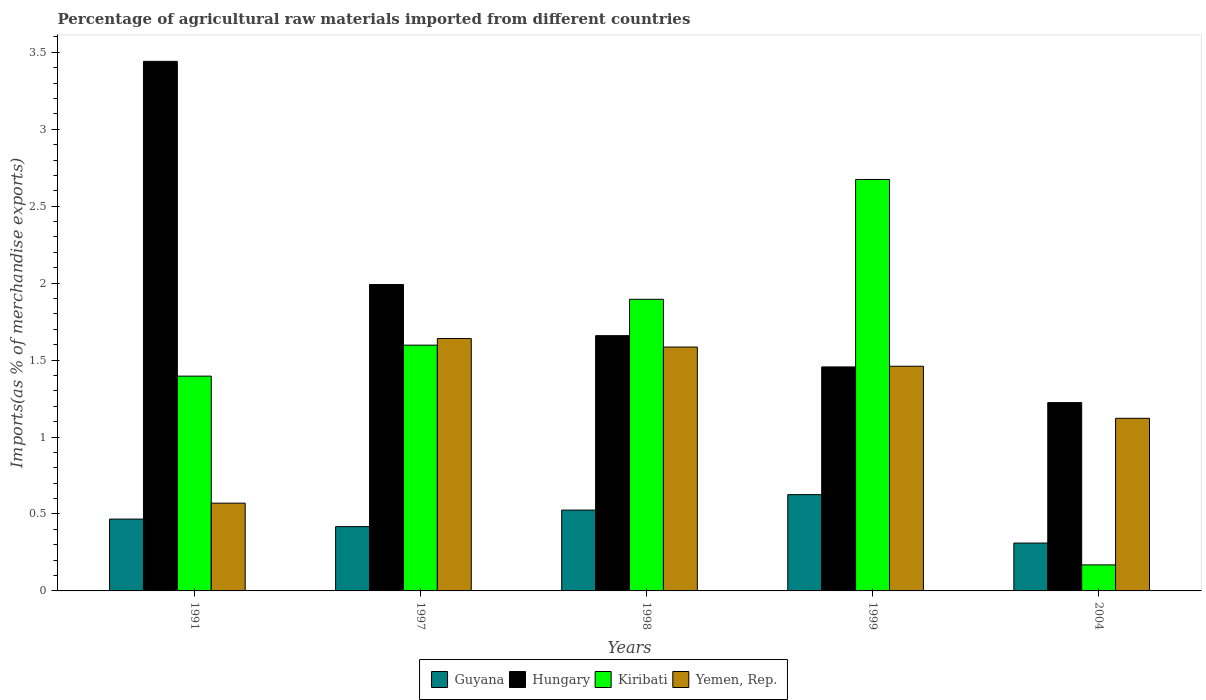Are the number of bars per tick equal to the number of legend labels?
Ensure brevity in your answer.  Yes. What is the label of the 3rd group of bars from the left?
Your answer should be very brief. 1998. What is the percentage of imports to different countries in Hungary in 1999?
Give a very brief answer. 1.46. Across all years, what is the maximum percentage of imports to different countries in Hungary?
Give a very brief answer. 3.44. Across all years, what is the minimum percentage of imports to different countries in Guyana?
Make the answer very short. 0.31. In which year was the percentage of imports to different countries in Guyana minimum?
Provide a short and direct response. 2004. What is the total percentage of imports to different countries in Yemen, Rep. in the graph?
Keep it short and to the point. 6.38. What is the difference between the percentage of imports to different countries in Hungary in 1991 and that in 1997?
Your answer should be compact. 1.45. What is the difference between the percentage of imports to different countries in Hungary in 1997 and the percentage of imports to different countries in Kiribati in 1991?
Offer a very short reply. 0.6. What is the average percentage of imports to different countries in Hungary per year?
Your response must be concise. 1.95. In the year 2004, what is the difference between the percentage of imports to different countries in Guyana and percentage of imports to different countries in Kiribati?
Offer a very short reply. 0.14. What is the ratio of the percentage of imports to different countries in Guyana in 1991 to that in 2004?
Provide a short and direct response. 1.5. Is the difference between the percentage of imports to different countries in Guyana in 1991 and 1997 greater than the difference between the percentage of imports to different countries in Kiribati in 1991 and 1997?
Ensure brevity in your answer.  Yes. What is the difference between the highest and the second highest percentage of imports to different countries in Hungary?
Your answer should be compact. 1.45. What is the difference between the highest and the lowest percentage of imports to different countries in Guyana?
Provide a succinct answer. 0.31. In how many years, is the percentage of imports to different countries in Guyana greater than the average percentage of imports to different countries in Guyana taken over all years?
Offer a terse response. 2. Is it the case that in every year, the sum of the percentage of imports to different countries in Guyana and percentage of imports to different countries in Yemen, Rep. is greater than the sum of percentage of imports to different countries in Hungary and percentage of imports to different countries in Kiribati?
Provide a succinct answer. No. What does the 3rd bar from the left in 1998 represents?
Your answer should be very brief. Kiribati. What does the 4th bar from the right in 1997 represents?
Ensure brevity in your answer.  Guyana. Is it the case that in every year, the sum of the percentage of imports to different countries in Yemen, Rep. and percentage of imports to different countries in Hungary is greater than the percentage of imports to different countries in Guyana?
Give a very brief answer. Yes. How many bars are there?
Make the answer very short. 20. Does the graph contain any zero values?
Keep it short and to the point. No. How many legend labels are there?
Give a very brief answer. 4. How are the legend labels stacked?
Your answer should be very brief. Horizontal. What is the title of the graph?
Your response must be concise. Percentage of agricultural raw materials imported from different countries. Does "Israel" appear as one of the legend labels in the graph?
Ensure brevity in your answer.  No. What is the label or title of the X-axis?
Your answer should be compact. Years. What is the label or title of the Y-axis?
Give a very brief answer. Imports(as % of merchandise exports). What is the Imports(as % of merchandise exports) of Guyana in 1991?
Offer a very short reply. 0.47. What is the Imports(as % of merchandise exports) of Hungary in 1991?
Ensure brevity in your answer.  3.44. What is the Imports(as % of merchandise exports) of Kiribati in 1991?
Provide a succinct answer. 1.4. What is the Imports(as % of merchandise exports) in Yemen, Rep. in 1991?
Give a very brief answer. 0.57. What is the Imports(as % of merchandise exports) of Guyana in 1997?
Make the answer very short. 0.42. What is the Imports(as % of merchandise exports) in Hungary in 1997?
Offer a very short reply. 1.99. What is the Imports(as % of merchandise exports) in Kiribati in 1997?
Offer a terse response. 1.6. What is the Imports(as % of merchandise exports) of Yemen, Rep. in 1997?
Keep it short and to the point. 1.64. What is the Imports(as % of merchandise exports) of Guyana in 1998?
Provide a short and direct response. 0.53. What is the Imports(as % of merchandise exports) of Hungary in 1998?
Your answer should be compact. 1.66. What is the Imports(as % of merchandise exports) in Kiribati in 1998?
Keep it short and to the point. 1.89. What is the Imports(as % of merchandise exports) in Yemen, Rep. in 1998?
Your answer should be compact. 1.58. What is the Imports(as % of merchandise exports) of Guyana in 1999?
Offer a very short reply. 0.63. What is the Imports(as % of merchandise exports) of Hungary in 1999?
Keep it short and to the point. 1.46. What is the Imports(as % of merchandise exports) in Kiribati in 1999?
Your answer should be very brief. 2.67. What is the Imports(as % of merchandise exports) in Yemen, Rep. in 1999?
Your response must be concise. 1.46. What is the Imports(as % of merchandise exports) of Guyana in 2004?
Make the answer very short. 0.31. What is the Imports(as % of merchandise exports) in Hungary in 2004?
Ensure brevity in your answer.  1.22. What is the Imports(as % of merchandise exports) of Kiribati in 2004?
Provide a short and direct response. 0.17. What is the Imports(as % of merchandise exports) of Yemen, Rep. in 2004?
Your answer should be compact. 1.12. Across all years, what is the maximum Imports(as % of merchandise exports) of Guyana?
Your response must be concise. 0.63. Across all years, what is the maximum Imports(as % of merchandise exports) in Hungary?
Provide a succinct answer. 3.44. Across all years, what is the maximum Imports(as % of merchandise exports) of Kiribati?
Your response must be concise. 2.67. Across all years, what is the maximum Imports(as % of merchandise exports) in Yemen, Rep.?
Make the answer very short. 1.64. Across all years, what is the minimum Imports(as % of merchandise exports) of Guyana?
Offer a terse response. 0.31. Across all years, what is the minimum Imports(as % of merchandise exports) in Hungary?
Offer a very short reply. 1.22. Across all years, what is the minimum Imports(as % of merchandise exports) of Kiribati?
Make the answer very short. 0.17. Across all years, what is the minimum Imports(as % of merchandise exports) of Yemen, Rep.?
Keep it short and to the point. 0.57. What is the total Imports(as % of merchandise exports) in Guyana in the graph?
Keep it short and to the point. 2.35. What is the total Imports(as % of merchandise exports) in Hungary in the graph?
Keep it short and to the point. 9.77. What is the total Imports(as % of merchandise exports) in Kiribati in the graph?
Provide a succinct answer. 7.73. What is the total Imports(as % of merchandise exports) in Yemen, Rep. in the graph?
Provide a succinct answer. 6.38. What is the difference between the Imports(as % of merchandise exports) of Guyana in 1991 and that in 1997?
Your answer should be very brief. 0.05. What is the difference between the Imports(as % of merchandise exports) in Hungary in 1991 and that in 1997?
Give a very brief answer. 1.45. What is the difference between the Imports(as % of merchandise exports) in Kiribati in 1991 and that in 1997?
Your answer should be very brief. -0.2. What is the difference between the Imports(as % of merchandise exports) in Yemen, Rep. in 1991 and that in 1997?
Make the answer very short. -1.07. What is the difference between the Imports(as % of merchandise exports) in Guyana in 1991 and that in 1998?
Your answer should be compact. -0.06. What is the difference between the Imports(as % of merchandise exports) of Hungary in 1991 and that in 1998?
Offer a very short reply. 1.78. What is the difference between the Imports(as % of merchandise exports) of Kiribati in 1991 and that in 1998?
Give a very brief answer. -0.5. What is the difference between the Imports(as % of merchandise exports) in Yemen, Rep. in 1991 and that in 1998?
Offer a terse response. -1.01. What is the difference between the Imports(as % of merchandise exports) in Guyana in 1991 and that in 1999?
Provide a short and direct response. -0.16. What is the difference between the Imports(as % of merchandise exports) in Hungary in 1991 and that in 1999?
Your answer should be compact. 1.99. What is the difference between the Imports(as % of merchandise exports) in Kiribati in 1991 and that in 1999?
Your answer should be very brief. -1.28. What is the difference between the Imports(as % of merchandise exports) of Yemen, Rep. in 1991 and that in 1999?
Provide a short and direct response. -0.89. What is the difference between the Imports(as % of merchandise exports) of Guyana in 1991 and that in 2004?
Ensure brevity in your answer.  0.16. What is the difference between the Imports(as % of merchandise exports) of Hungary in 1991 and that in 2004?
Provide a succinct answer. 2.22. What is the difference between the Imports(as % of merchandise exports) in Kiribati in 1991 and that in 2004?
Give a very brief answer. 1.23. What is the difference between the Imports(as % of merchandise exports) of Yemen, Rep. in 1991 and that in 2004?
Keep it short and to the point. -0.55. What is the difference between the Imports(as % of merchandise exports) in Guyana in 1997 and that in 1998?
Offer a very short reply. -0.11. What is the difference between the Imports(as % of merchandise exports) of Hungary in 1997 and that in 1998?
Your response must be concise. 0.33. What is the difference between the Imports(as % of merchandise exports) of Kiribati in 1997 and that in 1998?
Provide a succinct answer. -0.3. What is the difference between the Imports(as % of merchandise exports) of Yemen, Rep. in 1997 and that in 1998?
Your answer should be compact. 0.06. What is the difference between the Imports(as % of merchandise exports) in Guyana in 1997 and that in 1999?
Your response must be concise. -0.21. What is the difference between the Imports(as % of merchandise exports) in Hungary in 1997 and that in 1999?
Your response must be concise. 0.54. What is the difference between the Imports(as % of merchandise exports) of Kiribati in 1997 and that in 1999?
Your answer should be compact. -1.08. What is the difference between the Imports(as % of merchandise exports) in Yemen, Rep. in 1997 and that in 1999?
Your response must be concise. 0.18. What is the difference between the Imports(as % of merchandise exports) of Guyana in 1997 and that in 2004?
Your response must be concise. 0.11. What is the difference between the Imports(as % of merchandise exports) in Hungary in 1997 and that in 2004?
Provide a short and direct response. 0.77. What is the difference between the Imports(as % of merchandise exports) of Kiribati in 1997 and that in 2004?
Your answer should be very brief. 1.43. What is the difference between the Imports(as % of merchandise exports) in Yemen, Rep. in 1997 and that in 2004?
Keep it short and to the point. 0.52. What is the difference between the Imports(as % of merchandise exports) in Guyana in 1998 and that in 1999?
Give a very brief answer. -0.1. What is the difference between the Imports(as % of merchandise exports) in Hungary in 1998 and that in 1999?
Provide a succinct answer. 0.2. What is the difference between the Imports(as % of merchandise exports) of Kiribati in 1998 and that in 1999?
Provide a succinct answer. -0.78. What is the difference between the Imports(as % of merchandise exports) in Yemen, Rep. in 1998 and that in 1999?
Ensure brevity in your answer.  0.12. What is the difference between the Imports(as % of merchandise exports) in Guyana in 1998 and that in 2004?
Your answer should be very brief. 0.21. What is the difference between the Imports(as % of merchandise exports) in Hungary in 1998 and that in 2004?
Your answer should be very brief. 0.43. What is the difference between the Imports(as % of merchandise exports) in Kiribati in 1998 and that in 2004?
Your response must be concise. 1.73. What is the difference between the Imports(as % of merchandise exports) of Yemen, Rep. in 1998 and that in 2004?
Offer a terse response. 0.46. What is the difference between the Imports(as % of merchandise exports) of Guyana in 1999 and that in 2004?
Keep it short and to the point. 0.31. What is the difference between the Imports(as % of merchandise exports) in Hungary in 1999 and that in 2004?
Your answer should be compact. 0.23. What is the difference between the Imports(as % of merchandise exports) of Kiribati in 1999 and that in 2004?
Provide a succinct answer. 2.5. What is the difference between the Imports(as % of merchandise exports) in Yemen, Rep. in 1999 and that in 2004?
Provide a succinct answer. 0.34. What is the difference between the Imports(as % of merchandise exports) of Guyana in 1991 and the Imports(as % of merchandise exports) of Hungary in 1997?
Your response must be concise. -1.52. What is the difference between the Imports(as % of merchandise exports) of Guyana in 1991 and the Imports(as % of merchandise exports) of Kiribati in 1997?
Provide a succinct answer. -1.13. What is the difference between the Imports(as % of merchandise exports) in Guyana in 1991 and the Imports(as % of merchandise exports) in Yemen, Rep. in 1997?
Provide a succinct answer. -1.17. What is the difference between the Imports(as % of merchandise exports) of Hungary in 1991 and the Imports(as % of merchandise exports) of Kiribati in 1997?
Give a very brief answer. 1.84. What is the difference between the Imports(as % of merchandise exports) of Hungary in 1991 and the Imports(as % of merchandise exports) of Yemen, Rep. in 1997?
Provide a short and direct response. 1.8. What is the difference between the Imports(as % of merchandise exports) of Kiribati in 1991 and the Imports(as % of merchandise exports) of Yemen, Rep. in 1997?
Make the answer very short. -0.24. What is the difference between the Imports(as % of merchandise exports) of Guyana in 1991 and the Imports(as % of merchandise exports) of Hungary in 1998?
Offer a terse response. -1.19. What is the difference between the Imports(as % of merchandise exports) of Guyana in 1991 and the Imports(as % of merchandise exports) of Kiribati in 1998?
Offer a terse response. -1.43. What is the difference between the Imports(as % of merchandise exports) in Guyana in 1991 and the Imports(as % of merchandise exports) in Yemen, Rep. in 1998?
Your response must be concise. -1.12. What is the difference between the Imports(as % of merchandise exports) of Hungary in 1991 and the Imports(as % of merchandise exports) of Kiribati in 1998?
Your answer should be very brief. 1.55. What is the difference between the Imports(as % of merchandise exports) in Hungary in 1991 and the Imports(as % of merchandise exports) in Yemen, Rep. in 1998?
Make the answer very short. 1.86. What is the difference between the Imports(as % of merchandise exports) of Kiribati in 1991 and the Imports(as % of merchandise exports) of Yemen, Rep. in 1998?
Make the answer very short. -0.19. What is the difference between the Imports(as % of merchandise exports) in Guyana in 1991 and the Imports(as % of merchandise exports) in Hungary in 1999?
Offer a terse response. -0.99. What is the difference between the Imports(as % of merchandise exports) in Guyana in 1991 and the Imports(as % of merchandise exports) in Kiribati in 1999?
Your response must be concise. -2.21. What is the difference between the Imports(as % of merchandise exports) of Guyana in 1991 and the Imports(as % of merchandise exports) of Yemen, Rep. in 1999?
Offer a very short reply. -0.99. What is the difference between the Imports(as % of merchandise exports) of Hungary in 1991 and the Imports(as % of merchandise exports) of Kiribati in 1999?
Offer a terse response. 0.77. What is the difference between the Imports(as % of merchandise exports) in Hungary in 1991 and the Imports(as % of merchandise exports) in Yemen, Rep. in 1999?
Your response must be concise. 1.98. What is the difference between the Imports(as % of merchandise exports) in Kiribati in 1991 and the Imports(as % of merchandise exports) in Yemen, Rep. in 1999?
Give a very brief answer. -0.06. What is the difference between the Imports(as % of merchandise exports) in Guyana in 1991 and the Imports(as % of merchandise exports) in Hungary in 2004?
Offer a terse response. -0.76. What is the difference between the Imports(as % of merchandise exports) of Guyana in 1991 and the Imports(as % of merchandise exports) of Kiribati in 2004?
Your answer should be compact. 0.3. What is the difference between the Imports(as % of merchandise exports) in Guyana in 1991 and the Imports(as % of merchandise exports) in Yemen, Rep. in 2004?
Offer a terse response. -0.65. What is the difference between the Imports(as % of merchandise exports) in Hungary in 1991 and the Imports(as % of merchandise exports) in Kiribati in 2004?
Your answer should be very brief. 3.27. What is the difference between the Imports(as % of merchandise exports) in Hungary in 1991 and the Imports(as % of merchandise exports) in Yemen, Rep. in 2004?
Offer a terse response. 2.32. What is the difference between the Imports(as % of merchandise exports) in Kiribati in 1991 and the Imports(as % of merchandise exports) in Yemen, Rep. in 2004?
Make the answer very short. 0.27. What is the difference between the Imports(as % of merchandise exports) of Guyana in 1997 and the Imports(as % of merchandise exports) of Hungary in 1998?
Offer a terse response. -1.24. What is the difference between the Imports(as % of merchandise exports) of Guyana in 1997 and the Imports(as % of merchandise exports) of Kiribati in 1998?
Your answer should be very brief. -1.48. What is the difference between the Imports(as % of merchandise exports) in Guyana in 1997 and the Imports(as % of merchandise exports) in Yemen, Rep. in 1998?
Keep it short and to the point. -1.17. What is the difference between the Imports(as % of merchandise exports) in Hungary in 1997 and the Imports(as % of merchandise exports) in Kiribati in 1998?
Offer a terse response. 0.1. What is the difference between the Imports(as % of merchandise exports) of Hungary in 1997 and the Imports(as % of merchandise exports) of Yemen, Rep. in 1998?
Keep it short and to the point. 0.41. What is the difference between the Imports(as % of merchandise exports) of Kiribati in 1997 and the Imports(as % of merchandise exports) of Yemen, Rep. in 1998?
Make the answer very short. 0.01. What is the difference between the Imports(as % of merchandise exports) of Guyana in 1997 and the Imports(as % of merchandise exports) of Hungary in 1999?
Your response must be concise. -1.04. What is the difference between the Imports(as % of merchandise exports) of Guyana in 1997 and the Imports(as % of merchandise exports) of Kiribati in 1999?
Provide a succinct answer. -2.26. What is the difference between the Imports(as % of merchandise exports) in Guyana in 1997 and the Imports(as % of merchandise exports) in Yemen, Rep. in 1999?
Your answer should be compact. -1.04. What is the difference between the Imports(as % of merchandise exports) of Hungary in 1997 and the Imports(as % of merchandise exports) of Kiribati in 1999?
Your answer should be very brief. -0.68. What is the difference between the Imports(as % of merchandise exports) of Hungary in 1997 and the Imports(as % of merchandise exports) of Yemen, Rep. in 1999?
Your response must be concise. 0.53. What is the difference between the Imports(as % of merchandise exports) in Kiribati in 1997 and the Imports(as % of merchandise exports) in Yemen, Rep. in 1999?
Ensure brevity in your answer.  0.14. What is the difference between the Imports(as % of merchandise exports) in Guyana in 1997 and the Imports(as % of merchandise exports) in Hungary in 2004?
Your response must be concise. -0.81. What is the difference between the Imports(as % of merchandise exports) of Guyana in 1997 and the Imports(as % of merchandise exports) of Kiribati in 2004?
Make the answer very short. 0.25. What is the difference between the Imports(as % of merchandise exports) of Guyana in 1997 and the Imports(as % of merchandise exports) of Yemen, Rep. in 2004?
Offer a terse response. -0.7. What is the difference between the Imports(as % of merchandise exports) in Hungary in 1997 and the Imports(as % of merchandise exports) in Kiribati in 2004?
Make the answer very short. 1.82. What is the difference between the Imports(as % of merchandise exports) in Hungary in 1997 and the Imports(as % of merchandise exports) in Yemen, Rep. in 2004?
Provide a short and direct response. 0.87. What is the difference between the Imports(as % of merchandise exports) of Kiribati in 1997 and the Imports(as % of merchandise exports) of Yemen, Rep. in 2004?
Your response must be concise. 0.48. What is the difference between the Imports(as % of merchandise exports) of Guyana in 1998 and the Imports(as % of merchandise exports) of Hungary in 1999?
Make the answer very short. -0.93. What is the difference between the Imports(as % of merchandise exports) in Guyana in 1998 and the Imports(as % of merchandise exports) in Kiribati in 1999?
Offer a very short reply. -2.15. What is the difference between the Imports(as % of merchandise exports) of Guyana in 1998 and the Imports(as % of merchandise exports) of Yemen, Rep. in 1999?
Offer a terse response. -0.93. What is the difference between the Imports(as % of merchandise exports) of Hungary in 1998 and the Imports(as % of merchandise exports) of Kiribati in 1999?
Ensure brevity in your answer.  -1.01. What is the difference between the Imports(as % of merchandise exports) of Hungary in 1998 and the Imports(as % of merchandise exports) of Yemen, Rep. in 1999?
Keep it short and to the point. 0.2. What is the difference between the Imports(as % of merchandise exports) of Kiribati in 1998 and the Imports(as % of merchandise exports) of Yemen, Rep. in 1999?
Ensure brevity in your answer.  0.43. What is the difference between the Imports(as % of merchandise exports) in Guyana in 1998 and the Imports(as % of merchandise exports) in Hungary in 2004?
Your answer should be compact. -0.7. What is the difference between the Imports(as % of merchandise exports) of Guyana in 1998 and the Imports(as % of merchandise exports) of Kiribati in 2004?
Your answer should be compact. 0.36. What is the difference between the Imports(as % of merchandise exports) in Guyana in 1998 and the Imports(as % of merchandise exports) in Yemen, Rep. in 2004?
Your answer should be very brief. -0.6. What is the difference between the Imports(as % of merchandise exports) of Hungary in 1998 and the Imports(as % of merchandise exports) of Kiribati in 2004?
Make the answer very short. 1.49. What is the difference between the Imports(as % of merchandise exports) of Hungary in 1998 and the Imports(as % of merchandise exports) of Yemen, Rep. in 2004?
Provide a succinct answer. 0.54. What is the difference between the Imports(as % of merchandise exports) of Kiribati in 1998 and the Imports(as % of merchandise exports) of Yemen, Rep. in 2004?
Keep it short and to the point. 0.77. What is the difference between the Imports(as % of merchandise exports) of Guyana in 1999 and the Imports(as % of merchandise exports) of Hungary in 2004?
Ensure brevity in your answer.  -0.6. What is the difference between the Imports(as % of merchandise exports) in Guyana in 1999 and the Imports(as % of merchandise exports) in Kiribati in 2004?
Your answer should be very brief. 0.46. What is the difference between the Imports(as % of merchandise exports) in Guyana in 1999 and the Imports(as % of merchandise exports) in Yemen, Rep. in 2004?
Make the answer very short. -0.5. What is the difference between the Imports(as % of merchandise exports) of Hungary in 1999 and the Imports(as % of merchandise exports) of Kiribati in 2004?
Your response must be concise. 1.29. What is the difference between the Imports(as % of merchandise exports) in Hungary in 1999 and the Imports(as % of merchandise exports) in Yemen, Rep. in 2004?
Offer a terse response. 0.33. What is the difference between the Imports(as % of merchandise exports) in Kiribati in 1999 and the Imports(as % of merchandise exports) in Yemen, Rep. in 2004?
Keep it short and to the point. 1.55. What is the average Imports(as % of merchandise exports) in Guyana per year?
Give a very brief answer. 0.47. What is the average Imports(as % of merchandise exports) in Hungary per year?
Give a very brief answer. 1.95. What is the average Imports(as % of merchandise exports) of Kiribati per year?
Ensure brevity in your answer.  1.55. What is the average Imports(as % of merchandise exports) of Yemen, Rep. per year?
Keep it short and to the point. 1.28. In the year 1991, what is the difference between the Imports(as % of merchandise exports) of Guyana and Imports(as % of merchandise exports) of Hungary?
Give a very brief answer. -2.97. In the year 1991, what is the difference between the Imports(as % of merchandise exports) in Guyana and Imports(as % of merchandise exports) in Kiribati?
Give a very brief answer. -0.93. In the year 1991, what is the difference between the Imports(as % of merchandise exports) of Guyana and Imports(as % of merchandise exports) of Yemen, Rep.?
Offer a very short reply. -0.1. In the year 1991, what is the difference between the Imports(as % of merchandise exports) in Hungary and Imports(as % of merchandise exports) in Kiribati?
Provide a short and direct response. 2.05. In the year 1991, what is the difference between the Imports(as % of merchandise exports) of Hungary and Imports(as % of merchandise exports) of Yemen, Rep.?
Offer a terse response. 2.87. In the year 1991, what is the difference between the Imports(as % of merchandise exports) in Kiribati and Imports(as % of merchandise exports) in Yemen, Rep.?
Provide a short and direct response. 0.83. In the year 1997, what is the difference between the Imports(as % of merchandise exports) of Guyana and Imports(as % of merchandise exports) of Hungary?
Offer a very short reply. -1.57. In the year 1997, what is the difference between the Imports(as % of merchandise exports) in Guyana and Imports(as % of merchandise exports) in Kiribati?
Your answer should be very brief. -1.18. In the year 1997, what is the difference between the Imports(as % of merchandise exports) in Guyana and Imports(as % of merchandise exports) in Yemen, Rep.?
Your answer should be compact. -1.22. In the year 1997, what is the difference between the Imports(as % of merchandise exports) in Hungary and Imports(as % of merchandise exports) in Kiribati?
Give a very brief answer. 0.39. In the year 1997, what is the difference between the Imports(as % of merchandise exports) in Hungary and Imports(as % of merchandise exports) in Yemen, Rep.?
Make the answer very short. 0.35. In the year 1997, what is the difference between the Imports(as % of merchandise exports) of Kiribati and Imports(as % of merchandise exports) of Yemen, Rep.?
Your answer should be compact. -0.04. In the year 1998, what is the difference between the Imports(as % of merchandise exports) in Guyana and Imports(as % of merchandise exports) in Hungary?
Make the answer very short. -1.13. In the year 1998, what is the difference between the Imports(as % of merchandise exports) in Guyana and Imports(as % of merchandise exports) in Kiribati?
Your response must be concise. -1.37. In the year 1998, what is the difference between the Imports(as % of merchandise exports) in Guyana and Imports(as % of merchandise exports) in Yemen, Rep.?
Provide a short and direct response. -1.06. In the year 1998, what is the difference between the Imports(as % of merchandise exports) of Hungary and Imports(as % of merchandise exports) of Kiribati?
Your answer should be very brief. -0.24. In the year 1998, what is the difference between the Imports(as % of merchandise exports) of Hungary and Imports(as % of merchandise exports) of Yemen, Rep.?
Offer a terse response. 0.07. In the year 1998, what is the difference between the Imports(as % of merchandise exports) of Kiribati and Imports(as % of merchandise exports) of Yemen, Rep.?
Your answer should be very brief. 0.31. In the year 1999, what is the difference between the Imports(as % of merchandise exports) of Guyana and Imports(as % of merchandise exports) of Hungary?
Your response must be concise. -0.83. In the year 1999, what is the difference between the Imports(as % of merchandise exports) of Guyana and Imports(as % of merchandise exports) of Kiribati?
Give a very brief answer. -2.05. In the year 1999, what is the difference between the Imports(as % of merchandise exports) of Guyana and Imports(as % of merchandise exports) of Yemen, Rep.?
Provide a short and direct response. -0.83. In the year 1999, what is the difference between the Imports(as % of merchandise exports) in Hungary and Imports(as % of merchandise exports) in Kiribati?
Make the answer very short. -1.22. In the year 1999, what is the difference between the Imports(as % of merchandise exports) in Hungary and Imports(as % of merchandise exports) in Yemen, Rep.?
Provide a short and direct response. -0. In the year 1999, what is the difference between the Imports(as % of merchandise exports) of Kiribati and Imports(as % of merchandise exports) of Yemen, Rep.?
Offer a terse response. 1.21. In the year 2004, what is the difference between the Imports(as % of merchandise exports) of Guyana and Imports(as % of merchandise exports) of Hungary?
Your answer should be very brief. -0.91. In the year 2004, what is the difference between the Imports(as % of merchandise exports) of Guyana and Imports(as % of merchandise exports) of Kiribati?
Your answer should be compact. 0.14. In the year 2004, what is the difference between the Imports(as % of merchandise exports) in Guyana and Imports(as % of merchandise exports) in Yemen, Rep.?
Give a very brief answer. -0.81. In the year 2004, what is the difference between the Imports(as % of merchandise exports) of Hungary and Imports(as % of merchandise exports) of Kiribati?
Your response must be concise. 1.05. In the year 2004, what is the difference between the Imports(as % of merchandise exports) in Hungary and Imports(as % of merchandise exports) in Yemen, Rep.?
Your response must be concise. 0.1. In the year 2004, what is the difference between the Imports(as % of merchandise exports) of Kiribati and Imports(as % of merchandise exports) of Yemen, Rep.?
Your answer should be compact. -0.95. What is the ratio of the Imports(as % of merchandise exports) of Guyana in 1991 to that in 1997?
Offer a very short reply. 1.12. What is the ratio of the Imports(as % of merchandise exports) in Hungary in 1991 to that in 1997?
Your answer should be compact. 1.73. What is the ratio of the Imports(as % of merchandise exports) in Kiribati in 1991 to that in 1997?
Provide a short and direct response. 0.87. What is the ratio of the Imports(as % of merchandise exports) in Yemen, Rep. in 1991 to that in 1997?
Provide a short and direct response. 0.35. What is the ratio of the Imports(as % of merchandise exports) of Guyana in 1991 to that in 1998?
Your answer should be compact. 0.89. What is the ratio of the Imports(as % of merchandise exports) in Hungary in 1991 to that in 1998?
Give a very brief answer. 2.07. What is the ratio of the Imports(as % of merchandise exports) in Kiribati in 1991 to that in 1998?
Offer a terse response. 0.74. What is the ratio of the Imports(as % of merchandise exports) of Yemen, Rep. in 1991 to that in 1998?
Make the answer very short. 0.36. What is the ratio of the Imports(as % of merchandise exports) in Guyana in 1991 to that in 1999?
Ensure brevity in your answer.  0.75. What is the ratio of the Imports(as % of merchandise exports) in Hungary in 1991 to that in 1999?
Your answer should be compact. 2.36. What is the ratio of the Imports(as % of merchandise exports) of Kiribati in 1991 to that in 1999?
Offer a terse response. 0.52. What is the ratio of the Imports(as % of merchandise exports) of Yemen, Rep. in 1991 to that in 1999?
Ensure brevity in your answer.  0.39. What is the ratio of the Imports(as % of merchandise exports) in Guyana in 1991 to that in 2004?
Your answer should be compact. 1.5. What is the ratio of the Imports(as % of merchandise exports) in Hungary in 1991 to that in 2004?
Your response must be concise. 2.81. What is the ratio of the Imports(as % of merchandise exports) in Kiribati in 1991 to that in 2004?
Ensure brevity in your answer.  8.26. What is the ratio of the Imports(as % of merchandise exports) of Yemen, Rep. in 1991 to that in 2004?
Provide a succinct answer. 0.51. What is the ratio of the Imports(as % of merchandise exports) in Guyana in 1997 to that in 1998?
Give a very brief answer. 0.8. What is the ratio of the Imports(as % of merchandise exports) of Hungary in 1997 to that in 1998?
Ensure brevity in your answer.  1.2. What is the ratio of the Imports(as % of merchandise exports) in Kiribati in 1997 to that in 1998?
Give a very brief answer. 0.84. What is the ratio of the Imports(as % of merchandise exports) of Yemen, Rep. in 1997 to that in 1998?
Make the answer very short. 1.04. What is the ratio of the Imports(as % of merchandise exports) in Guyana in 1997 to that in 1999?
Your answer should be compact. 0.67. What is the ratio of the Imports(as % of merchandise exports) of Hungary in 1997 to that in 1999?
Give a very brief answer. 1.37. What is the ratio of the Imports(as % of merchandise exports) of Kiribati in 1997 to that in 1999?
Your response must be concise. 0.6. What is the ratio of the Imports(as % of merchandise exports) in Yemen, Rep. in 1997 to that in 1999?
Offer a terse response. 1.12. What is the ratio of the Imports(as % of merchandise exports) in Guyana in 1997 to that in 2004?
Give a very brief answer. 1.34. What is the ratio of the Imports(as % of merchandise exports) in Hungary in 1997 to that in 2004?
Make the answer very short. 1.63. What is the ratio of the Imports(as % of merchandise exports) of Kiribati in 1997 to that in 2004?
Your answer should be compact. 9.45. What is the ratio of the Imports(as % of merchandise exports) of Yemen, Rep. in 1997 to that in 2004?
Provide a succinct answer. 1.46. What is the ratio of the Imports(as % of merchandise exports) in Guyana in 1998 to that in 1999?
Ensure brevity in your answer.  0.84. What is the ratio of the Imports(as % of merchandise exports) of Hungary in 1998 to that in 1999?
Ensure brevity in your answer.  1.14. What is the ratio of the Imports(as % of merchandise exports) in Kiribati in 1998 to that in 1999?
Provide a short and direct response. 0.71. What is the ratio of the Imports(as % of merchandise exports) of Yemen, Rep. in 1998 to that in 1999?
Provide a short and direct response. 1.09. What is the ratio of the Imports(as % of merchandise exports) in Guyana in 1998 to that in 2004?
Provide a succinct answer. 1.69. What is the ratio of the Imports(as % of merchandise exports) of Hungary in 1998 to that in 2004?
Give a very brief answer. 1.36. What is the ratio of the Imports(as % of merchandise exports) in Kiribati in 1998 to that in 2004?
Ensure brevity in your answer.  11.21. What is the ratio of the Imports(as % of merchandise exports) of Yemen, Rep. in 1998 to that in 2004?
Make the answer very short. 1.41. What is the ratio of the Imports(as % of merchandise exports) of Guyana in 1999 to that in 2004?
Your response must be concise. 2.01. What is the ratio of the Imports(as % of merchandise exports) in Hungary in 1999 to that in 2004?
Provide a short and direct response. 1.19. What is the ratio of the Imports(as % of merchandise exports) in Kiribati in 1999 to that in 2004?
Give a very brief answer. 15.81. What is the ratio of the Imports(as % of merchandise exports) of Yemen, Rep. in 1999 to that in 2004?
Give a very brief answer. 1.3. What is the difference between the highest and the second highest Imports(as % of merchandise exports) of Guyana?
Provide a succinct answer. 0.1. What is the difference between the highest and the second highest Imports(as % of merchandise exports) in Hungary?
Your answer should be compact. 1.45. What is the difference between the highest and the second highest Imports(as % of merchandise exports) of Kiribati?
Your answer should be very brief. 0.78. What is the difference between the highest and the second highest Imports(as % of merchandise exports) of Yemen, Rep.?
Offer a terse response. 0.06. What is the difference between the highest and the lowest Imports(as % of merchandise exports) of Guyana?
Your answer should be compact. 0.31. What is the difference between the highest and the lowest Imports(as % of merchandise exports) of Hungary?
Give a very brief answer. 2.22. What is the difference between the highest and the lowest Imports(as % of merchandise exports) in Kiribati?
Your response must be concise. 2.5. What is the difference between the highest and the lowest Imports(as % of merchandise exports) of Yemen, Rep.?
Your answer should be very brief. 1.07. 